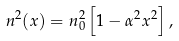Convert formula to latex. <formula><loc_0><loc_0><loc_500><loc_500>n ^ { 2 } ( x ) = n _ { 0 } ^ { 2 } \left [ 1 - \alpha ^ { 2 } x ^ { 2 } \right ] ,</formula> 